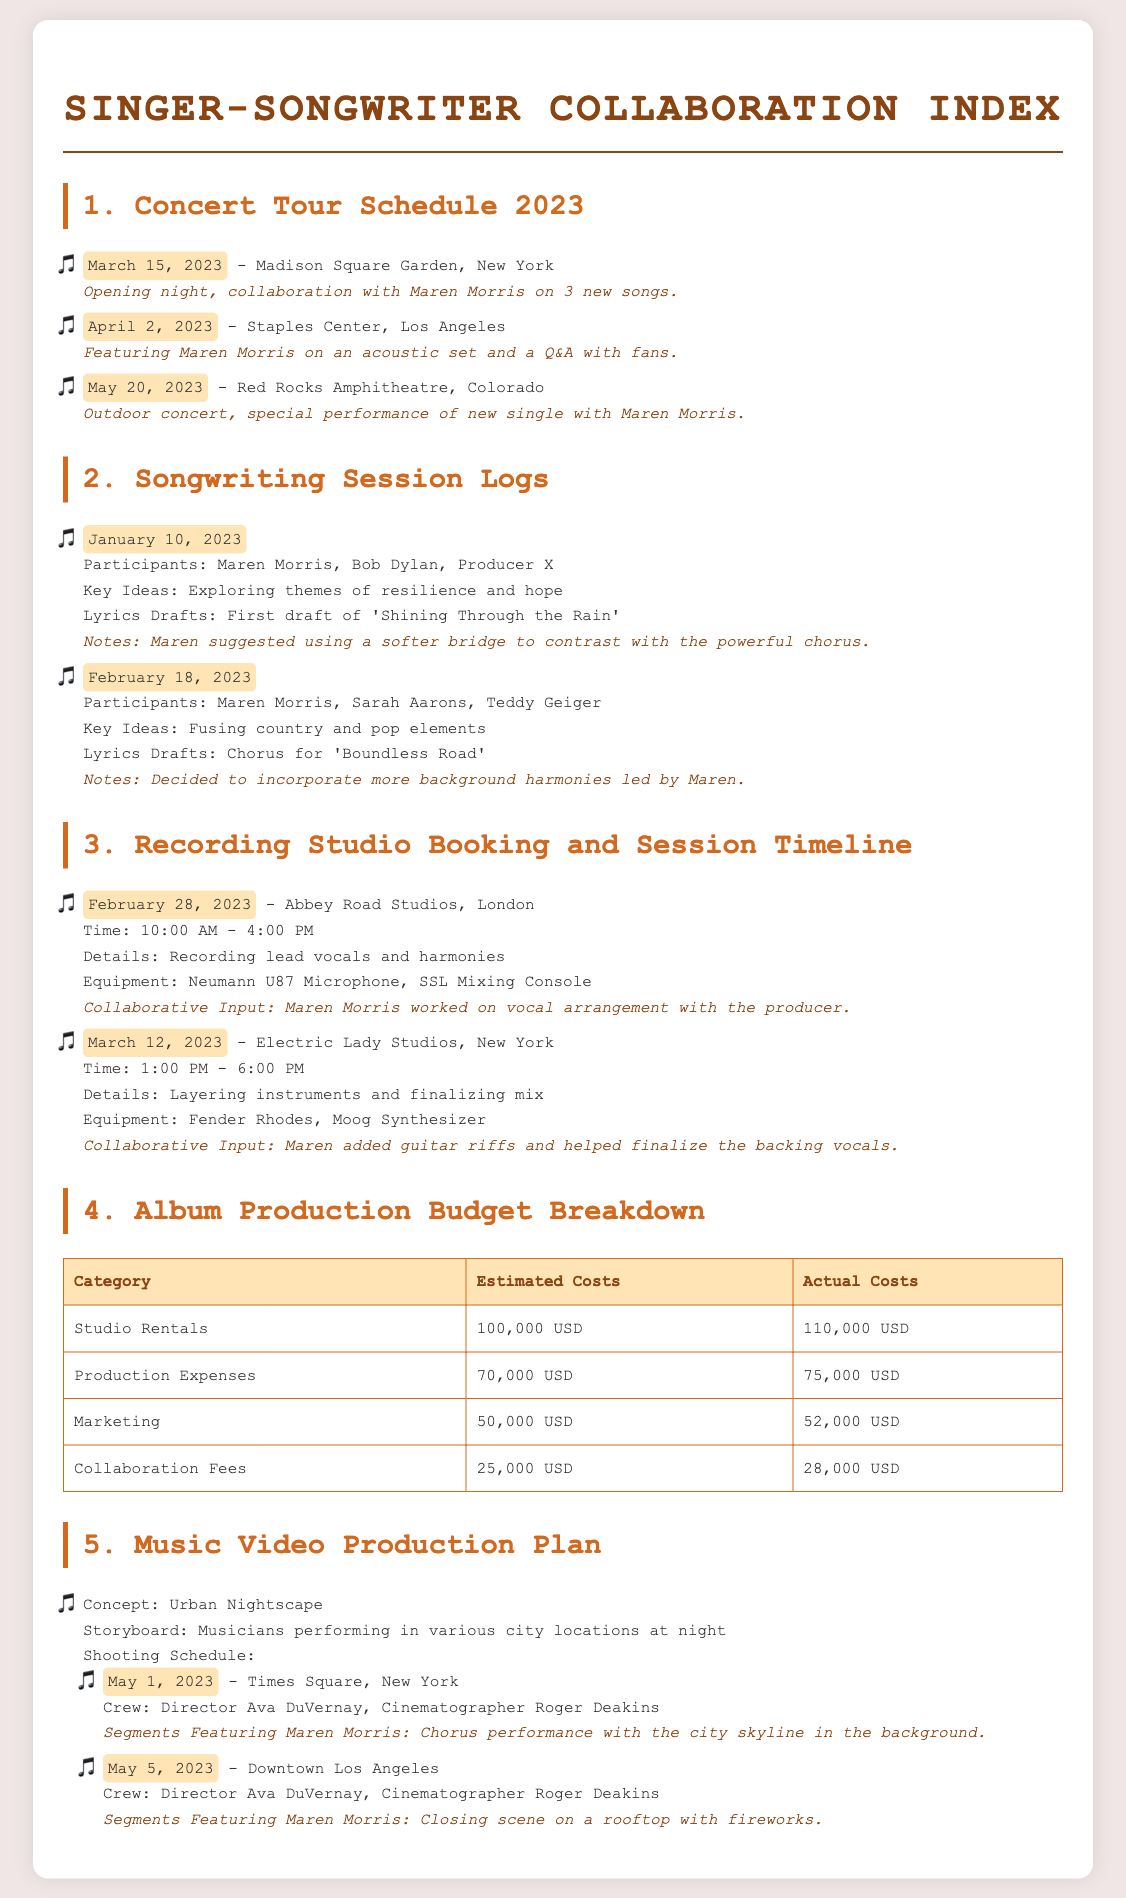What is the date of the concert at Madison Square Garden? The document lists the concert date at Madison Square Garden as March 15, 2023.
Answer: March 15, 2023 What is one key idea from the songwriting session on January 10, 2023? The key idea from the session on January 10, 2023, was exploring themes of resilience and hope.
Answer: Resilience and hope How much was the estimated cost for studio rentals? The document states the estimated cost for studio rentals is 100,000 USD.
Answer: 100,000 USD Where will the music video segment featuring Maren Morris shooting take place on May 1, 2023? The segment on May 1, 2023, will take place in Times Square, New York.
Answer: Times Square, New York Who is the cinematographer for the music video? The cinematographer mentioned in the document for the music video is Roger Deakins.
Answer: Roger Deakins What was Maren Morris's suggestion for the bridge of 'Shining Through the Rain'? Maren suggested using a softer bridge to contrast with the powerful chorus.
Answer: Softer bridge What is the venue for the concert on April 2, 2023? The concert on April 2, 2023, is at Staples Center, Los Angeles.
Answer: Staples Center, Los Angeles How many new songs were performed together on March 15, 2023? The concert on March 15, 2023, featured collaboration on 3 new songs.
Answer: 3 new songs What was the actual cost for collaboration fees? The actual cost for collaboration fees listed in the document is 28,000 USD.
Answer: 28,000 USD 